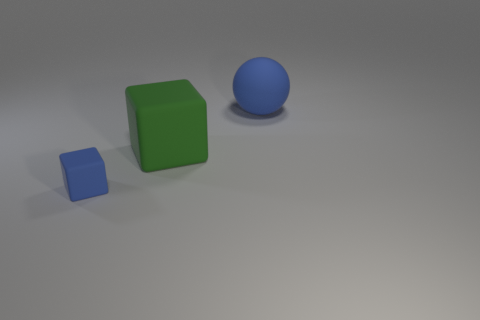Add 3 large cyan cylinders. How many objects exist? 6 Subtract all blue blocks. How many blocks are left? 1 Subtract 2 blocks. How many blocks are left? 0 Add 2 big blue rubber objects. How many big blue rubber objects exist? 3 Subtract 0 gray cylinders. How many objects are left? 3 Subtract all cubes. How many objects are left? 1 Subtract all red cubes. Subtract all cyan balls. How many cubes are left? 2 Subtract all big rubber spheres. Subtract all big matte cubes. How many objects are left? 1 Add 1 large blue things. How many large blue things are left? 2 